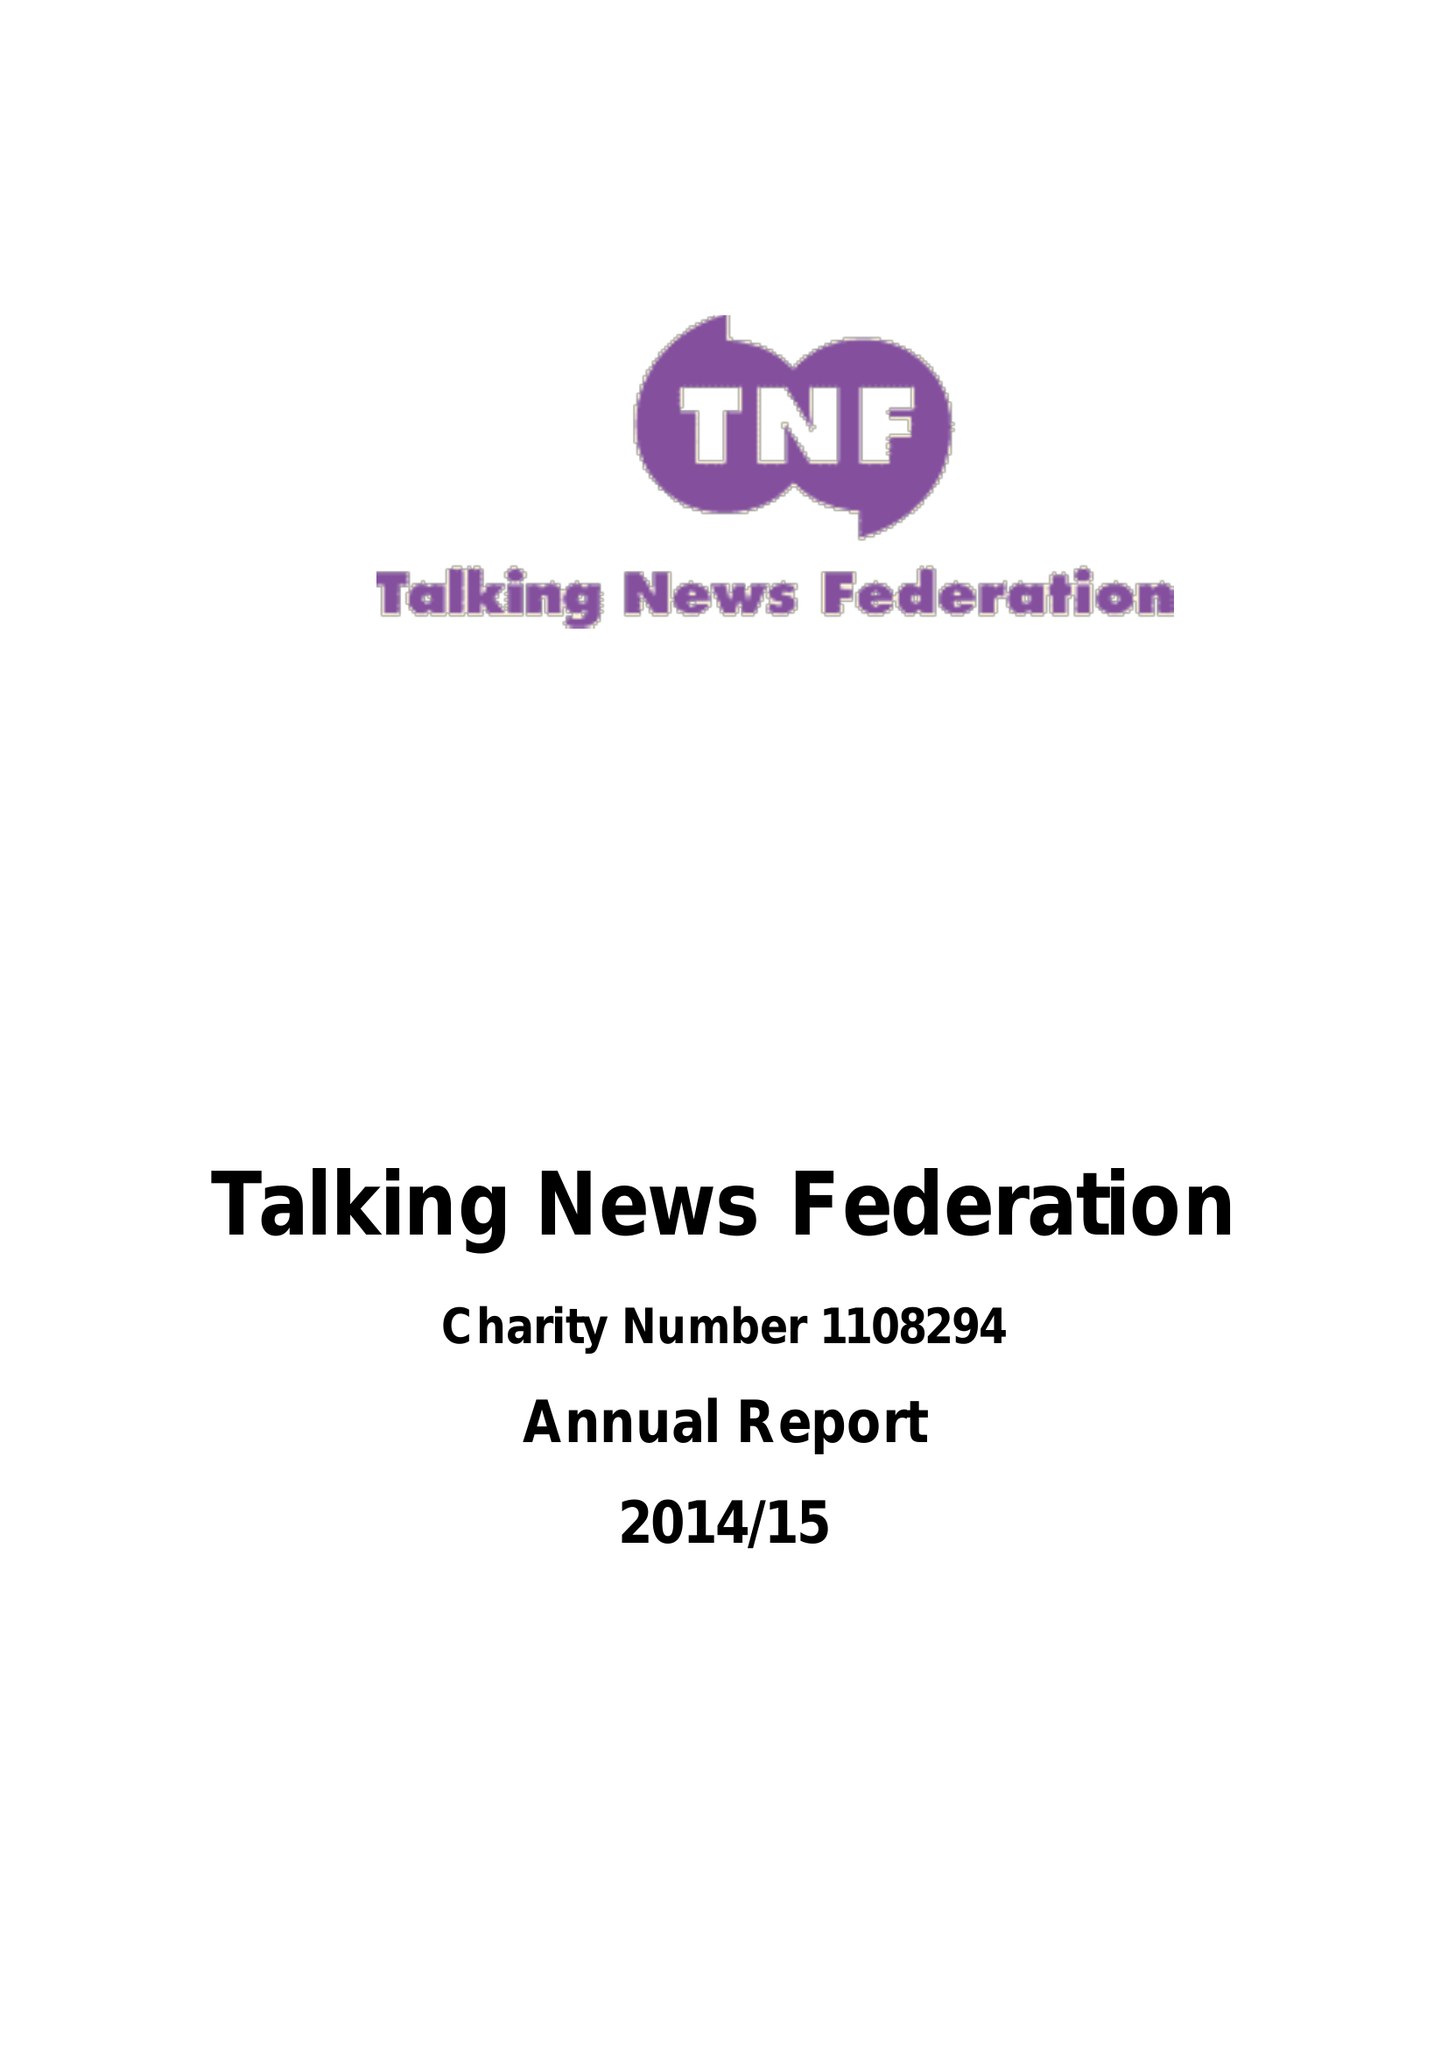What is the value for the address__street_line?
Answer the question using a single word or phrase. 145 VICTORIA ROAD 